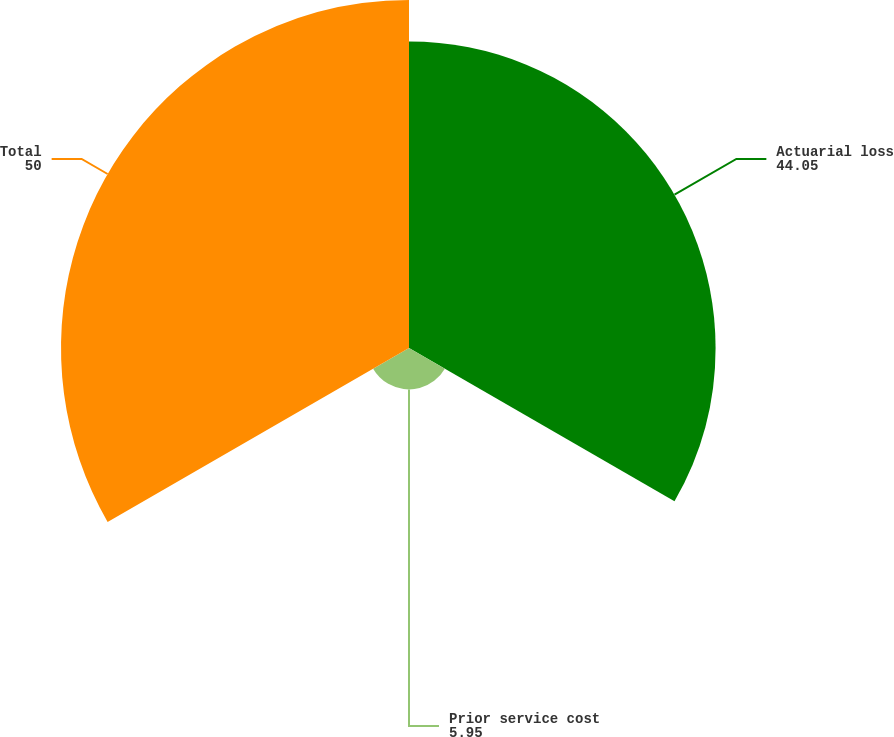<chart> <loc_0><loc_0><loc_500><loc_500><pie_chart><fcel>Actuarial loss<fcel>Prior service cost<fcel>Total<nl><fcel>44.05%<fcel>5.95%<fcel>50.0%<nl></chart> 